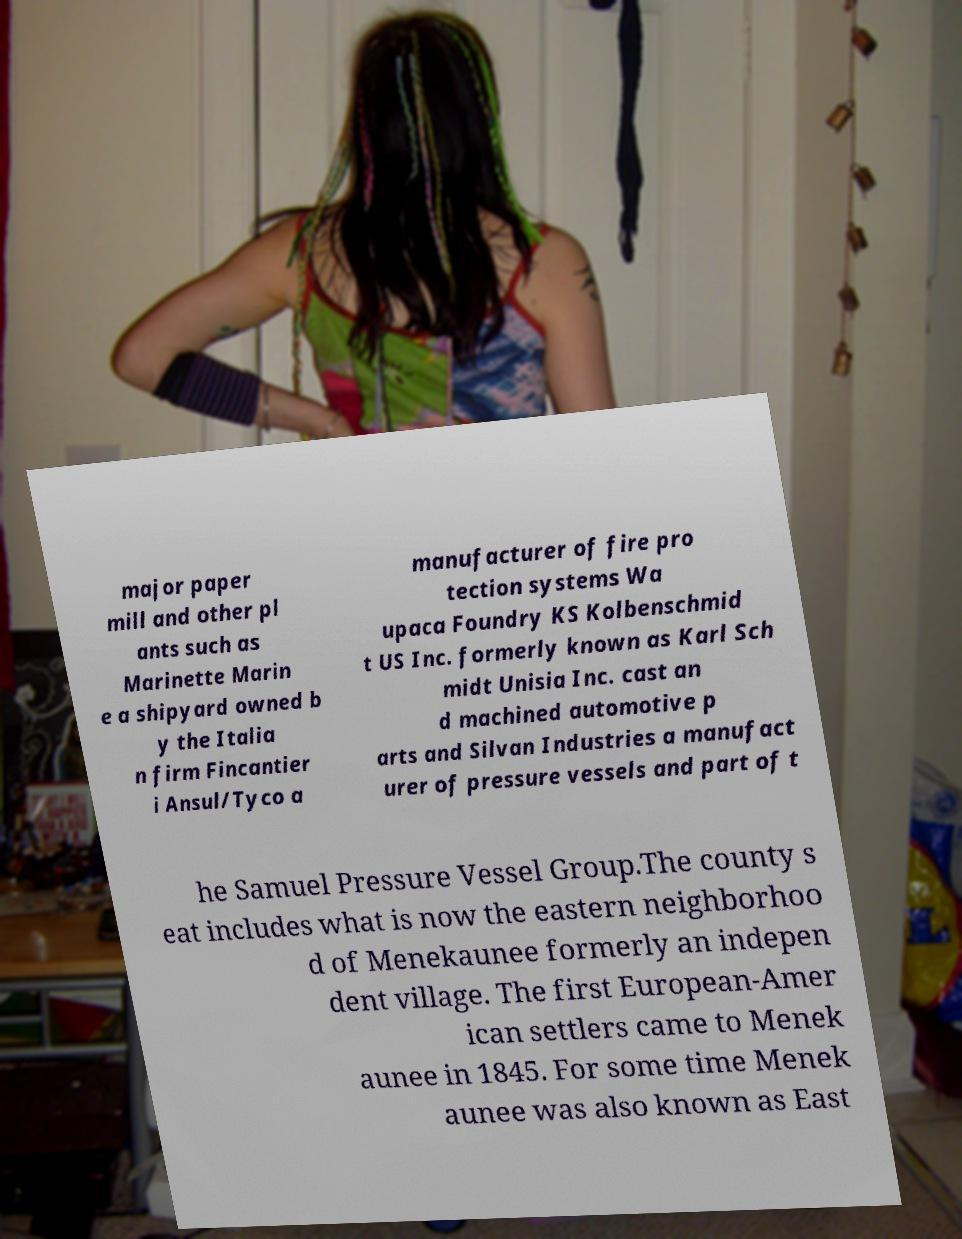Could you assist in decoding the text presented in this image and type it out clearly? major paper mill and other pl ants such as Marinette Marin e a shipyard owned b y the Italia n firm Fincantier i Ansul/Tyco a manufacturer of fire pro tection systems Wa upaca Foundry KS Kolbenschmid t US Inc. formerly known as Karl Sch midt Unisia Inc. cast an d machined automotive p arts and Silvan Industries a manufact urer of pressure vessels and part of t he Samuel Pressure Vessel Group.The county s eat includes what is now the eastern neighborhoo d of Menekaunee formerly an indepen dent village. The first European-Amer ican settlers came to Menek aunee in 1845. For some time Menek aunee was also known as East 